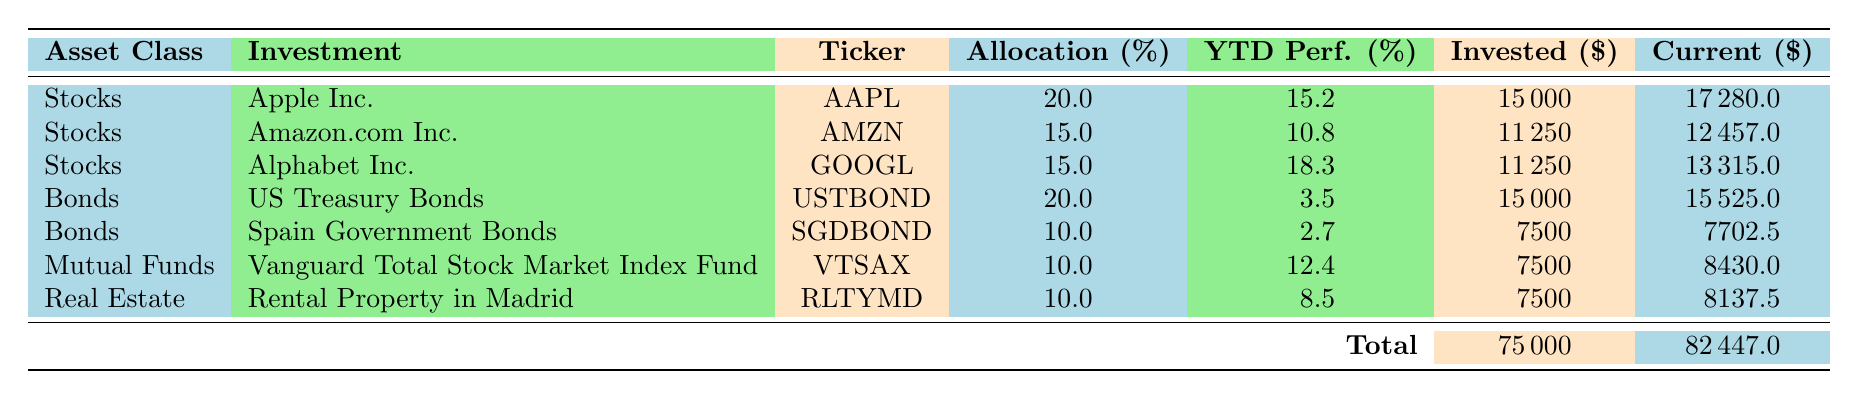What is the current value of Apple Inc. in the portfolio? The current value for Apple Inc. is listed in the "Current ($)" column, which is 17280.0.
Answer: 17280.0 What is the total amount invested in Bonds? Two bond investments are listed: US Treasury Bonds with 15000 and Spain Government Bonds with 7500. By summing these amounts, we find 15000 + 7500 = 22500.
Answer: 22500 Which investment has the highest Year-to-Date performance? The "YTD Perf. (%)" column shows Apple Inc. with 15.2%, Alphabet Inc. with 18.3%, and others. Alphabet Inc. has the highest value at 18.3%.
Answer: Alphabet Inc Is the total current value greater than the total amount invested? The total current value is 82447.0, and the total invested is 75000. Since 82447.0 > 75000, the answer is yes.
Answer: Yes What percentage of the total investment is allocated to Mutual Funds? The Mutual Fund investment in the table has an allocation of 10%, which can be checked directly in the "Allocation (%)" column.
Answer: 10% What is the average Year-to-Date performance of all investments? The YTD performances are: 15.2, 10.8, 18.3, 3.5, 2.7, 12.4, and 8.5. Summing these values gives 71.0. Dividing by the total number of investments (7), results in 71.0 / 7 = 10.14.
Answer: 10.14 Which asset class contributes most to the total investment? The total investments for each asset class must be calculated: Stocks (37500), Bonds (22500), Mutual Funds (7500), and Real Estate (7500). Stocks have the highest amount, which is 37500.
Answer: Stocks What is the total allocation percentage across all investments? The allocation percentages are: 20, 15, 15, 20, 10, 10, and 10. Their sum yields 100%, as the allocations match the total investment profile.
Answer: 100% How much has been invested in Spain Government Bonds? The amount invested in Spain Government Bonds is directly stated in the "Invested ($)" column as 7500.
Answer: 7500 